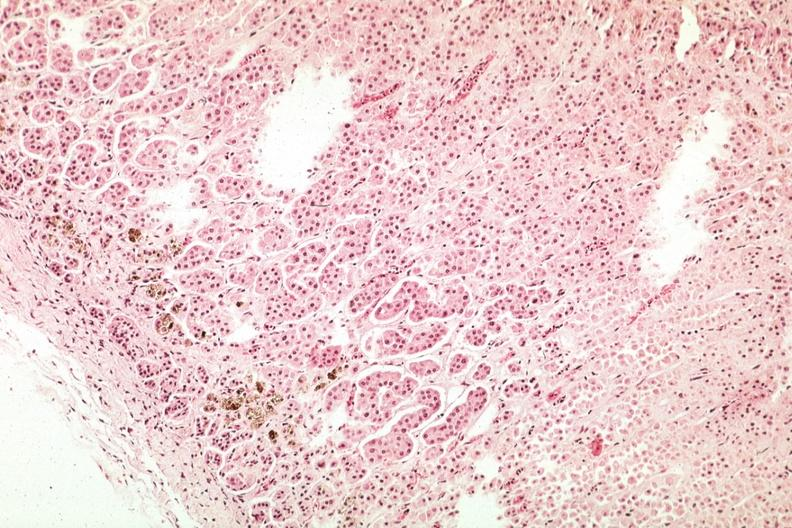what is present?
Answer the question using a single word or phrase. Adrenal 